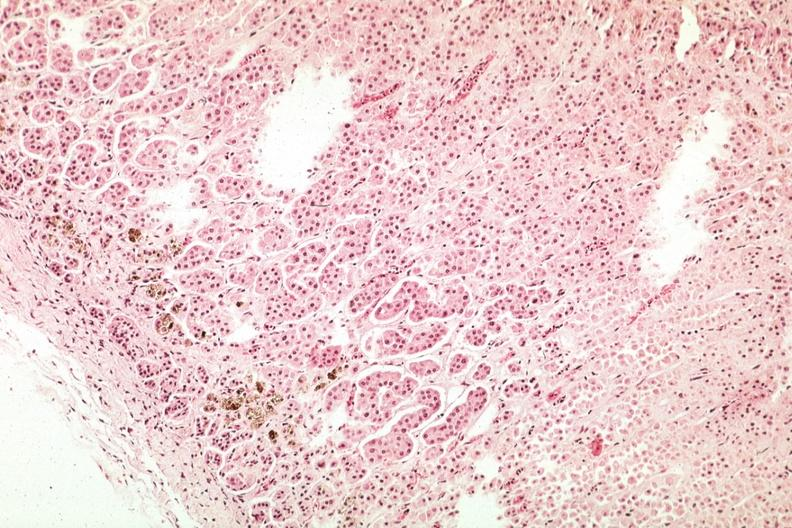what is present?
Answer the question using a single word or phrase. Adrenal 